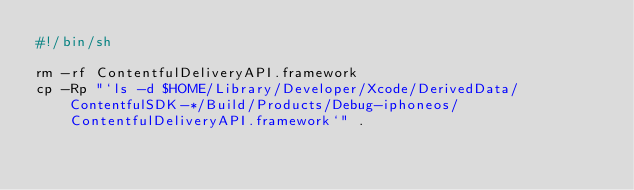<code> <loc_0><loc_0><loc_500><loc_500><_Bash_>#!/bin/sh

rm -rf ContentfulDeliveryAPI.framework
cp -Rp "`ls -d $HOME/Library/Developer/Xcode/DerivedData/ContentfulSDK-*/Build/Products/Debug-iphoneos/ContentfulDeliveryAPI.framework`" .
</code> 